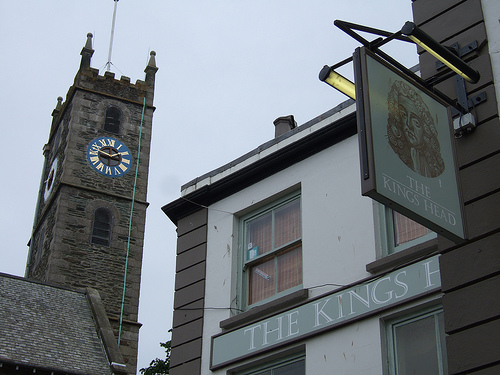Describe the architectural style of the building seen in the image. The building displays a traditional British architectural style, featuring a stone facade with detailed window framing and a distinctly shaped curved window on the top floor. 